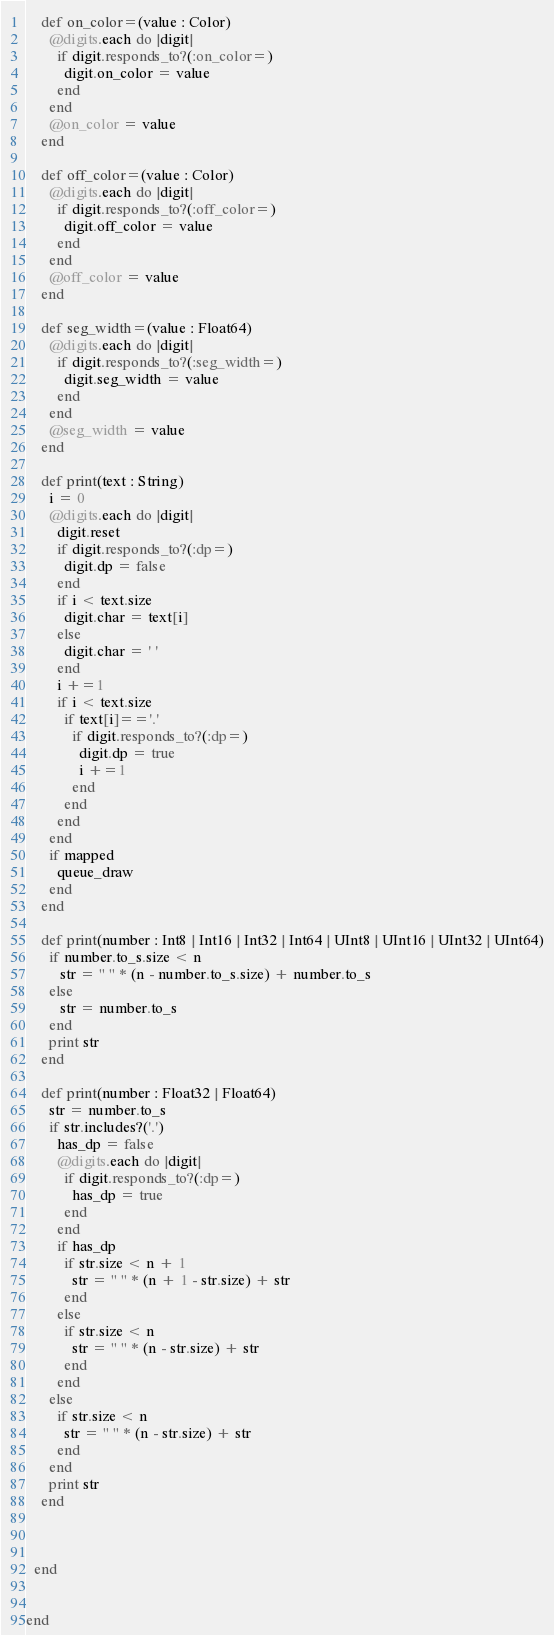Convert code to text. <code><loc_0><loc_0><loc_500><loc_500><_Crystal_>    def on_color=(value : Color)
      @digits.each do |digit|
        if digit.responds_to?(:on_color=)
          digit.on_color = value
        end
      end
      @on_color = value
    end 

    def off_color=(value : Color)
      @digits.each do |digit|
        if digit.responds_to?(:off_color=)
          digit.off_color = value
        end
      end
      @off_color = value
    end 

    def seg_width=(value : Float64)
      @digits.each do |digit|
        if digit.responds_to?(:seg_width=)
          digit.seg_width = value
        end
      end
      @seg_width = value
    end

    def print(text : String)
      i = 0
      @digits.each do |digit|
        digit.reset
        if digit.responds_to?(:dp=)
          digit.dp = false
        end
        if i < text.size
          digit.char = text[i]
        else
          digit.char = ' '
        end 
        i +=1
        if i < text.size
          if text[i]=='.'
            if digit.responds_to?(:dp=)
              digit.dp = true
              i +=1
            end
          end
        end
      end
      if mapped
        queue_draw
      end
    end

    def print(number : Int8 | Int16 | Int32 | Int64 | UInt8 | UInt16 | UInt32 | UInt64)
      if number.to_s.size < n
         str = " " * (n - number.to_s.size) + number.to_s
      else
         str = number.to_s
      end
      print str 
    end

    def print(number : Float32 | Float64)
      str = number.to_s
      if str.includes?('.')
        has_dp = false
        @digits.each do |digit|
          if digit.responds_to?(:dp=)
            has_dp = true
          end
        end
        if has_dp
          if str.size < n + 1
            str = " " * (n + 1 - str.size) + str
          end 
        else
          if str.size < n
            str = " " * (n - str.size) + str
          end
        end
      else
        if str.size < n
          str = " " * (n - str.size) + str
        end
      end
      print str
    end

    

  end


end
</code> 